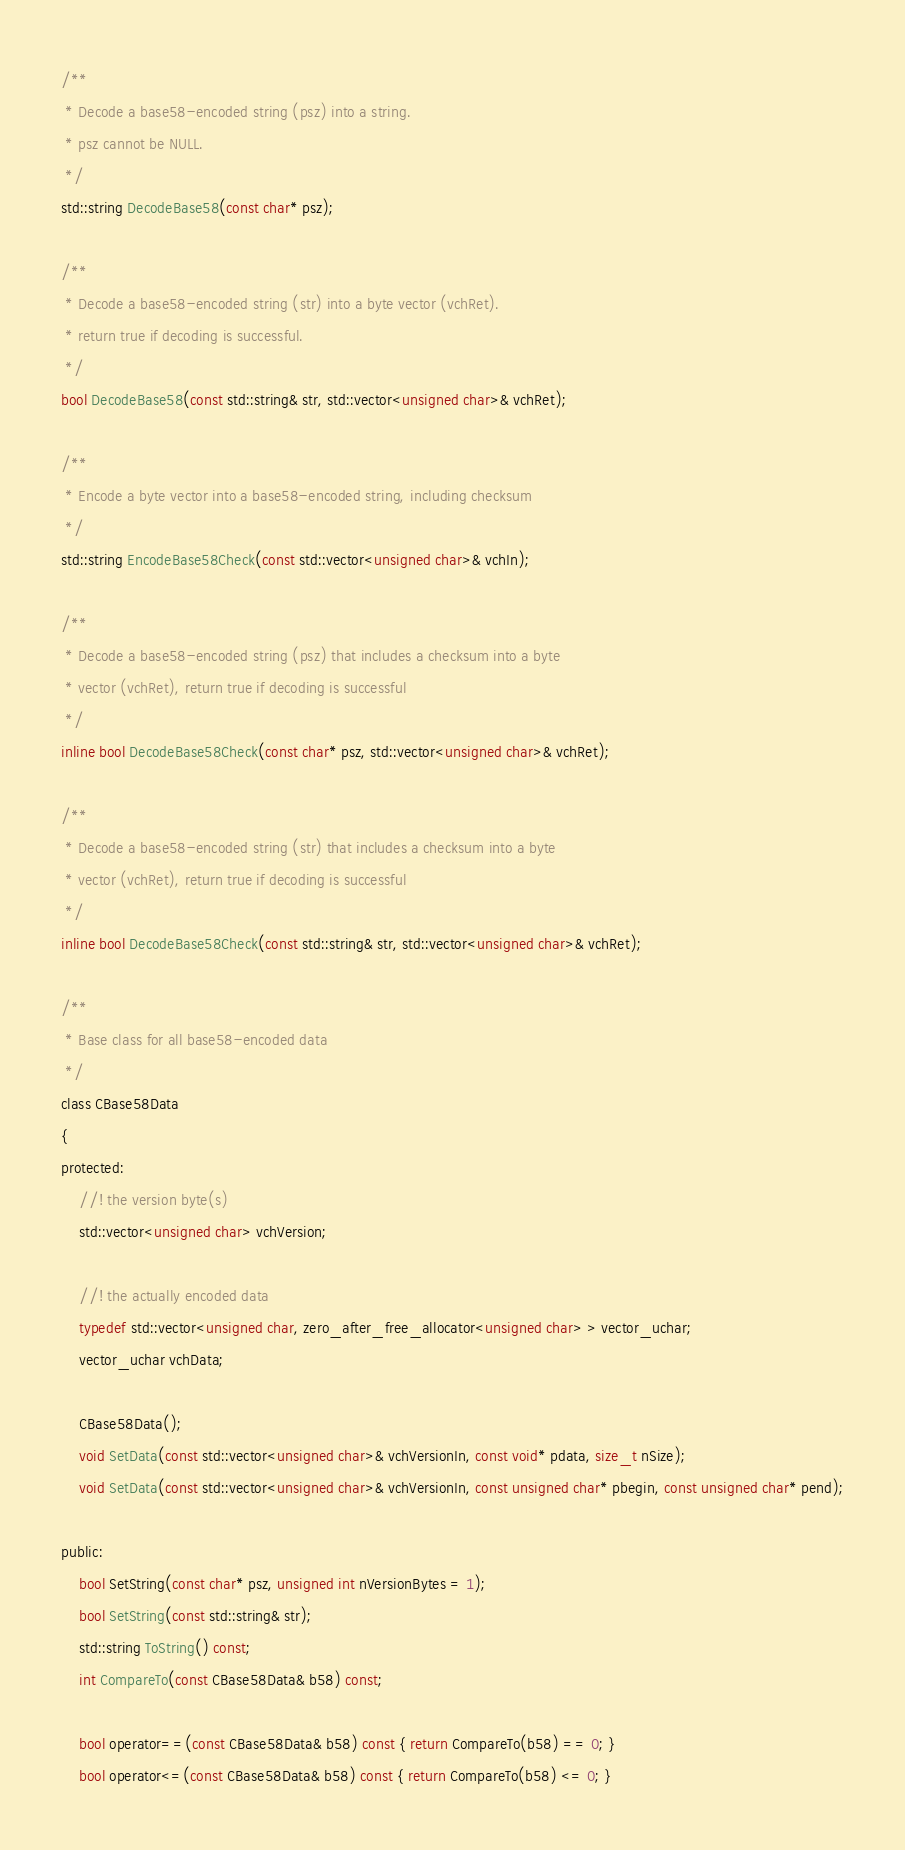<code> <loc_0><loc_0><loc_500><loc_500><_C_>/**
 * Decode a base58-encoded string (psz) into a string.
 * psz cannot be NULL.
 */
std::string DecodeBase58(const char* psz);

/**
 * Decode a base58-encoded string (str) into a byte vector (vchRet).
 * return true if decoding is successful.
 */
bool DecodeBase58(const std::string& str, std::vector<unsigned char>& vchRet);

/**
 * Encode a byte vector into a base58-encoded string, including checksum
 */
std::string EncodeBase58Check(const std::vector<unsigned char>& vchIn);

/**
 * Decode a base58-encoded string (psz) that includes a checksum into a byte
 * vector (vchRet), return true if decoding is successful
 */
inline bool DecodeBase58Check(const char* psz, std::vector<unsigned char>& vchRet);

/**
 * Decode a base58-encoded string (str) that includes a checksum into a byte
 * vector (vchRet), return true if decoding is successful
 */
inline bool DecodeBase58Check(const std::string& str, std::vector<unsigned char>& vchRet);

/**
 * Base class for all base58-encoded data
 */
class CBase58Data
{
protected:
    //! the version byte(s)
    std::vector<unsigned char> vchVersion;

    //! the actually encoded data
    typedef std::vector<unsigned char, zero_after_free_allocator<unsigned char> > vector_uchar;
    vector_uchar vchData;

    CBase58Data();
    void SetData(const std::vector<unsigned char>& vchVersionIn, const void* pdata, size_t nSize);
    void SetData(const std::vector<unsigned char>& vchVersionIn, const unsigned char* pbegin, const unsigned char* pend);

public:
    bool SetString(const char* psz, unsigned int nVersionBytes = 1);
    bool SetString(const std::string& str);
    std::string ToString() const;
    int CompareTo(const CBase58Data& b58) const;

    bool operator==(const CBase58Data& b58) const { return CompareTo(b58) == 0; }
    bool operator<=(const CBase58Data& b58) const { return CompareTo(b58) <= 0; }</code> 